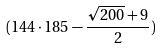Convert formula to latex. <formula><loc_0><loc_0><loc_500><loc_500>( 1 4 4 \cdot 1 8 5 - \frac { \sqrt { 2 0 0 } + 9 } { 2 } )</formula> 